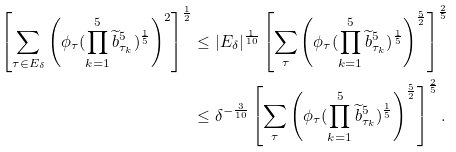<formula> <loc_0><loc_0><loc_500><loc_500>\left [ \sum _ { \tau \in E _ { \delta } } \left ( \phi _ { \tau } ( \prod _ { k = 1 } ^ { 5 } \widetilde { b } ^ { 5 } _ { \tau _ { k } } ) ^ { \frac { 1 } { 5 } } \right ) ^ { 2 } \right ] ^ { \frac { 1 } { 2 } } & \leq | E _ { \delta } | ^ { \frac { 1 } { 1 0 } } \left [ \sum _ { \tau } \left ( \phi _ { \tau } ( \prod _ { k = 1 } ^ { 5 } \widetilde { b } ^ { 5 } _ { \tau _ { k } } ) ^ { \frac { 1 } { 5 } } \right ) ^ { \frac { 5 } { 2 } } \right ] ^ { \frac { 2 } { 5 } } \\ & \leq \delta ^ { - \frac { 3 } { 1 0 } } \left [ \sum _ { \tau } \left ( \phi _ { \tau } ( \prod _ { k = 1 } ^ { 5 } \widetilde { b } ^ { 5 } _ { \tau _ { k } } ) ^ { \frac { 1 } { 5 } } \right ) ^ { \frac { 5 } { 2 } } \right ] ^ { \frac { 2 } { 5 } } .</formula> 